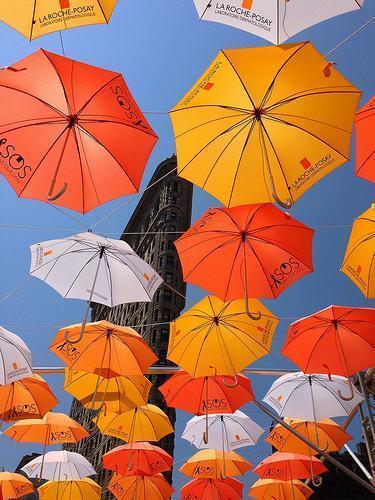How many red umbrellas are in the air?
Give a very brief answer. 8. How many yellow umbrellas are in the air?
Give a very brief answer. 7. How many white umbrellas are in the air?
Give a very brief answer. 6. 